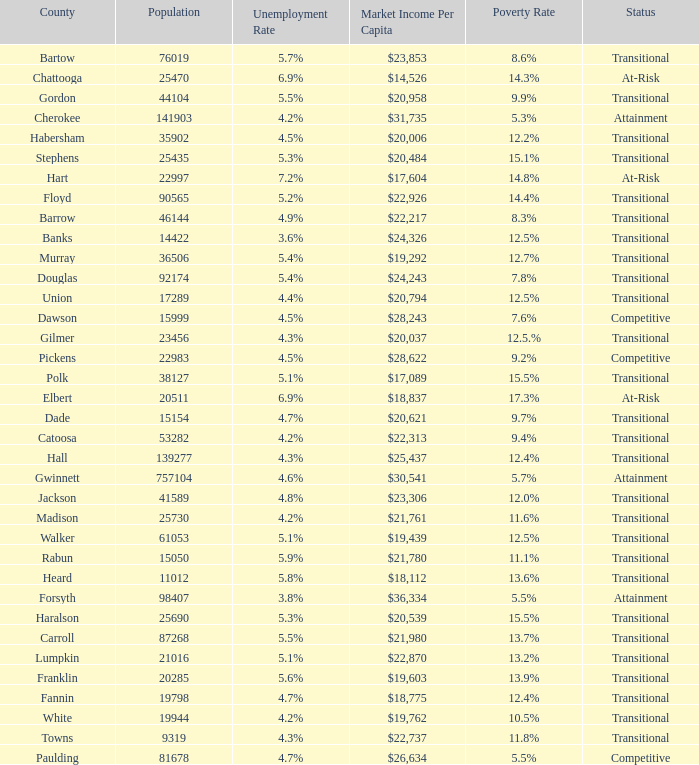What is the status of the county with per capita market income of $24,326? Transitional. 